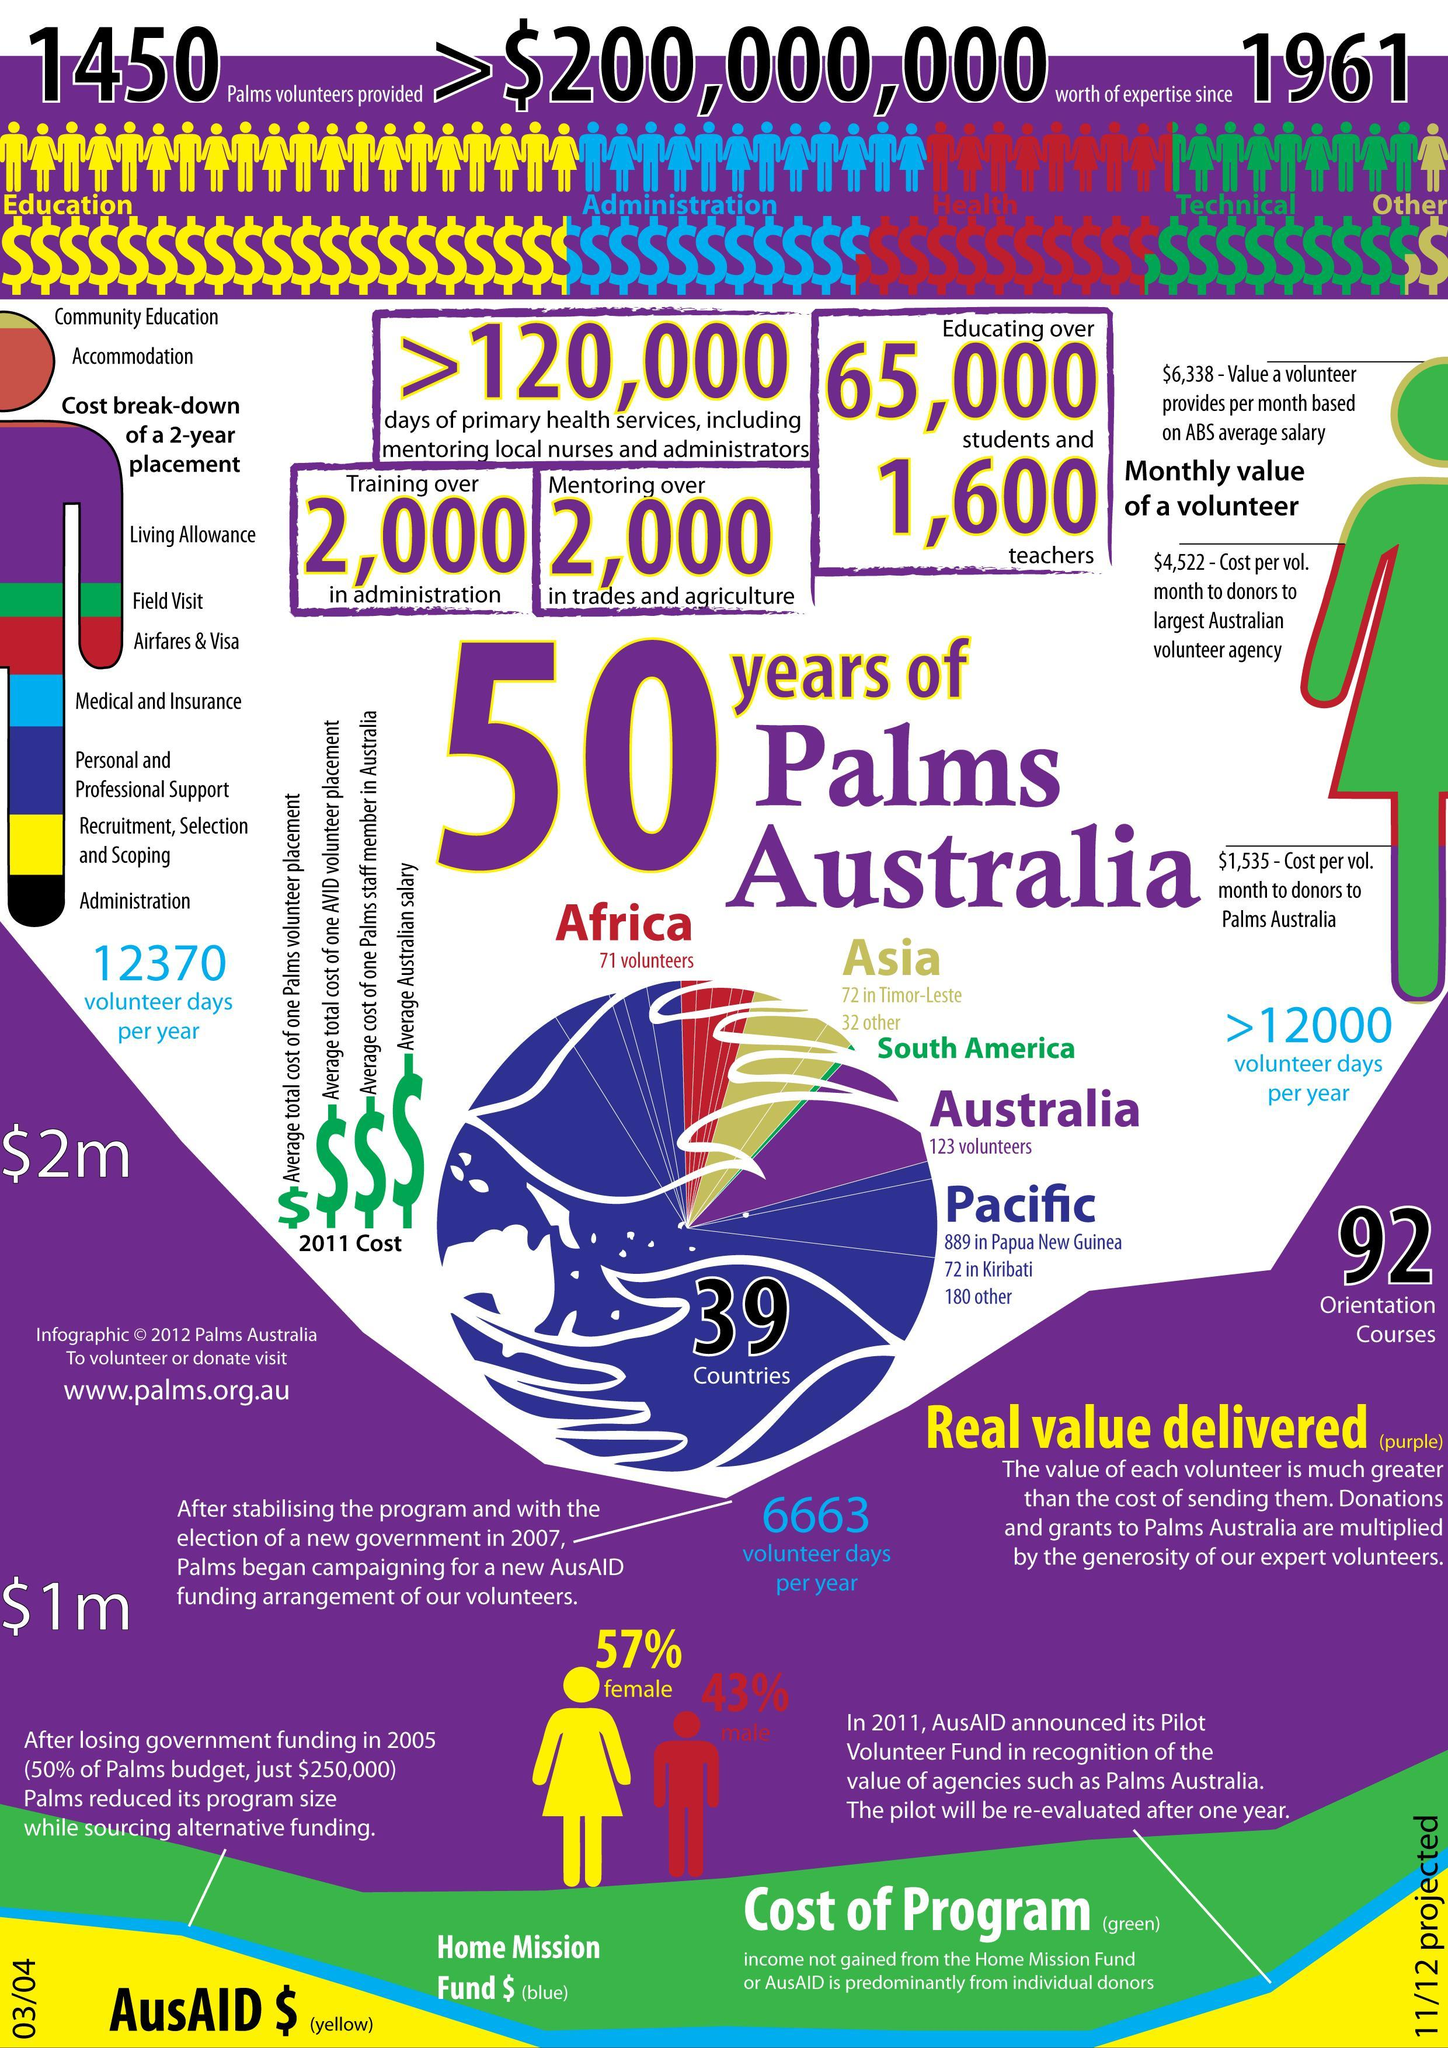How many people are undergoing training in administration?
Answer the question with a short phrase. 2,000 How many students are being educated by Palms Australia? 65,000 How many people are get trained in trade and agriculture? 2,000 How many volunteers are there from Africa for Palms Australia? 71 volunteers How many teachers are working with Palms Australia? 1,600 